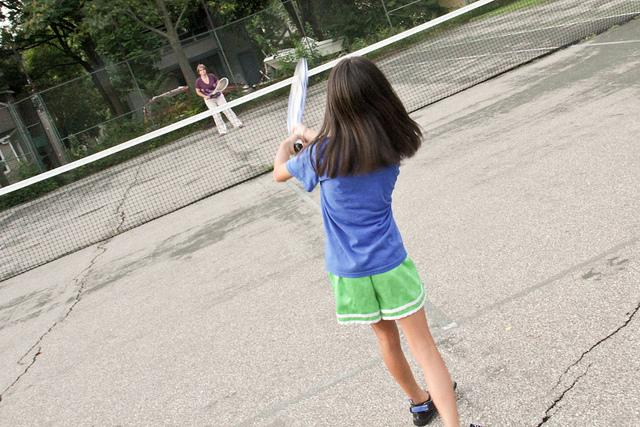Where does the girl want to hit the ball? over net 